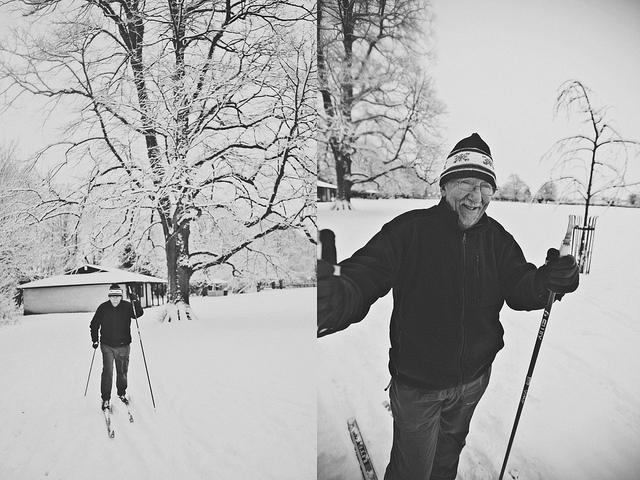How many people can you see?
Give a very brief answer. 2. How many buses are solid blue?
Give a very brief answer. 0. 